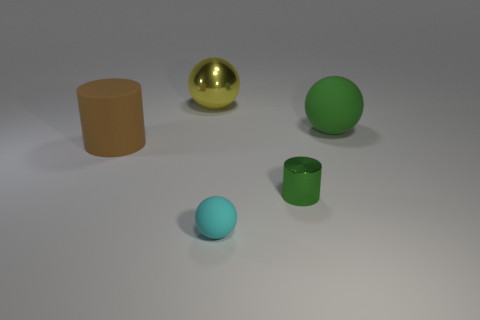Add 1 small purple cylinders. How many objects exist? 6 Subtract all cylinders. How many objects are left? 3 Add 2 large gray shiny cubes. How many large gray shiny cubes exist? 2 Subtract 0 gray spheres. How many objects are left? 5 Subtract all tiny purple rubber blocks. Subtract all large green objects. How many objects are left? 4 Add 2 big rubber cylinders. How many big rubber cylinders are left? 3 